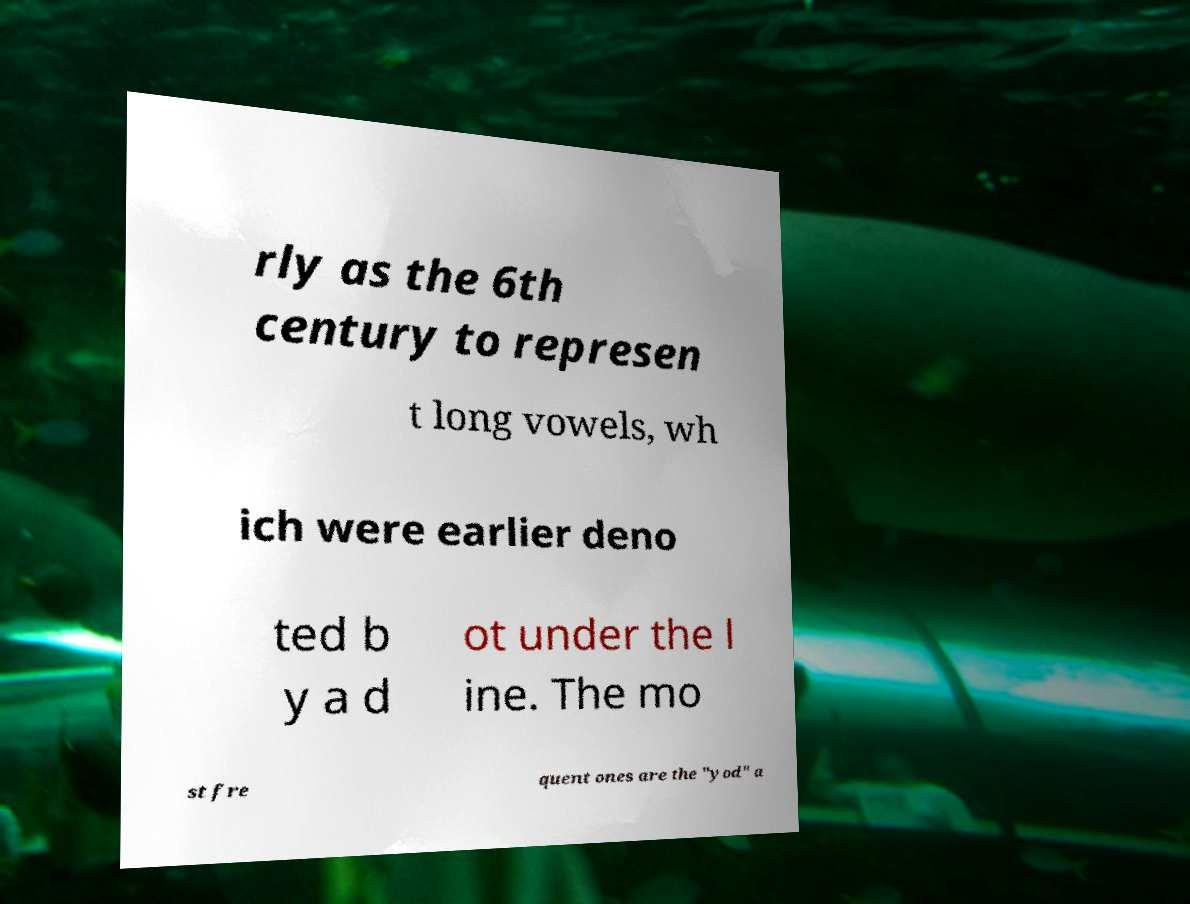Please identify and transcribe the text found in this image. rly as the 6th century to represen t long vowels, wh ich were earlier deno ted b y a d ot under the l ine. The mo st fre quent ones are the "yod" a 